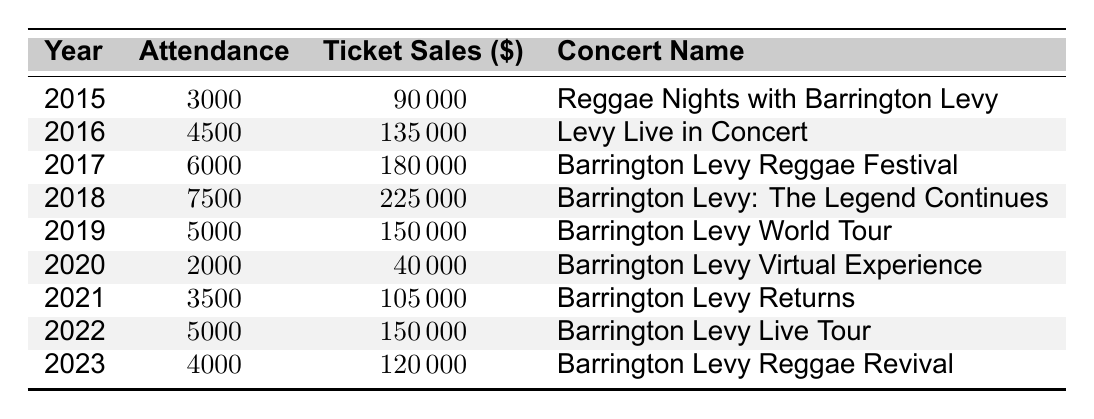What was the highest concert attendance for Barrington Levy? The highest attendance is found by looking for the maximum value in the attendance column. The maximum attendance is 7500 in the year 2018 for the concert "Barrington Levy: The Legend Continues."
Answer: 7500 In which year did Barrington Levy have the lowest ticket sales? By examining the ticket sales column, the lowest figure is 40000 in the year 2020 for the concert "Barrington Levy Virtual Experience."
Answer: 40000 How many total attendees did Barrington Levy have across all concerts from 2015 to 2023? We sum all attendance values: 3000 + 4500 + 6000 + 7500 + 5000 + 2000 + 3500 + 5000 + 4000 = 30000.
Answer: 30000 What is the average ticket sales per concert from 2015 to 2023? To find the average, we sum all ticket sales to get 90000 + 135000 + 180000 + 225000 + 150000 + 40000 + 105000 + 150000 + 120000 = 1080000, and divide by the number of concerts, which is 9. Therefore, 1080000 / 9 = 120000.
Answer: 120000 Did Barrington Levy's attendance increase every year from 2015 to 2019? Checking the attendance values year by year: 3000 (2015), 4500 (2016), 6000 (2017), 7500 (2018), but then it decreased to 5000 (2019). Therefore, attendance did not increase every year.
Answer: No In which concert year did Barrington Levy have a ticket sale equal to 150000? Looking at the ticket sales column, we find that the year 2019 and 2022 both had ticket sales of 150000.
Answer: 2019 and 2022 What was the difference in attendance between the highest and lowest concert attendance? The highest attendance is 7500 (in 2018), and the lowest is 2000 (in 2020). The difference is 7500 - 2000 = 5500.
Answer: 5500 Which concert had the highest ticket sales, and what were those sales? The highest ticket sales can be identified from the table, which shows that the concert in 2018, "Barrington Levy: The Legend Continues," had ticket sales of 225000.
Answer: 225000 What percentage of total ticket sales in 2020 did the ticket sales from the concert in 2018 represent? First, we identify the ticket sales for both years: 40000 (2020) and 225000 (2018). The percentage is calculated as (225000 / 40000) * 100 = 562.5%.
Answer: 562.5% 